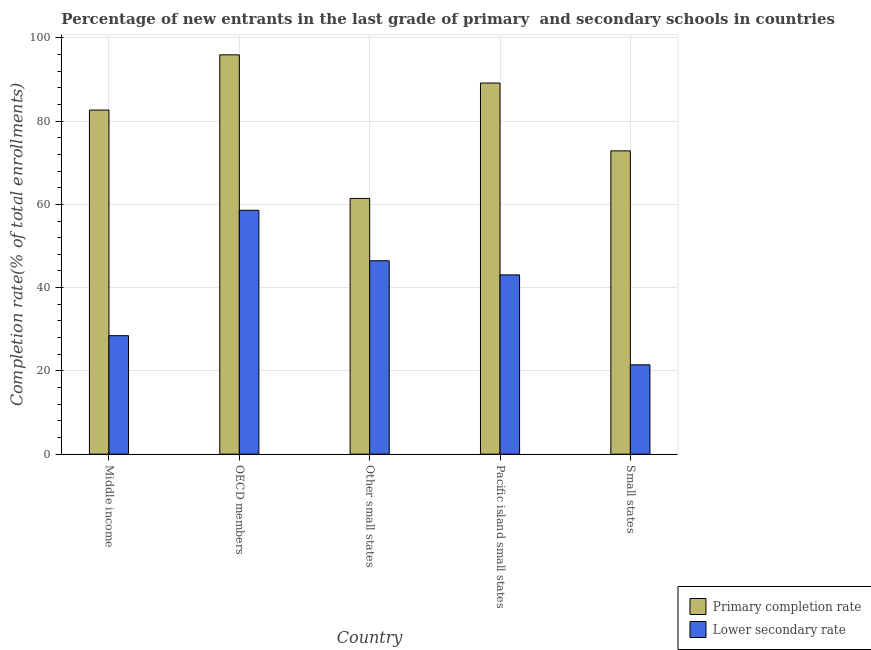How many groups of bars are there?
Make the answer very short. 5. How many bars are there on the 2nd tick from the left?
Provide a short and direct response. 2. What is the completion rate in secondary schools in Small states?
Offer a terse response. 21.46. Across all countries, what is the maximum completion rate in primary schools?
Ensure brevity in your answer.  95.91. Across all countries, what is the minimum completion rate in secondary schools?
Your answer should be compact. 21.46. In which country was the completion rate in secondary schools maximum?
Keep it short and to the point. OECD members. In which country was the completion rate in secondary schools minimum?
Keep it short and to the point. Small states. What is the total completion rate in secondary schools in the graph?
Keep it short and to the point. 198.01. What is the difference between the completion rate in primary schools in Other small states and that in Pacific island small states?
Your response must be concise. -27.72. What is the difference between the completion rate in secondary schools in Small states and the completion rate in primary schools in Other small states?
Your answer should be very brief. -39.96. What is the average completion rate in primary schools per country?
Your answer should be very brief. 80.4. What is the difference between the completion rate in secondary schools and completion rate in primary schools in Small states?
Provide a succinct answer. -51.39. What is the ratio of the completion rate in secondary schools in Pacific island small states to that in Small states?
Your answer should be compact. 2.01. Is the difference between the completion rate in primary schools in OECD members and Other small states greater than the difference between the completion rate in secondary schools in OECD members and Other small states?
Provide a succinct answer. Yes. What is the difference between the highest and the second highest completion rate in primary schools?
Your response must be concise. 6.76. What is the difference between the highest and the lowest completion rate in primary schools?
Give a very brief answer. 34.49. What does the 1st bar from the left in Small states represents?
Keep it short and to the point. Primary completion rate. What does the 2nd bar from the right in Pacific island small states represents?
Offer a terse response. Primary completion rate. Are all the bars in the graph horizontal?
Offer a very short reply. No. Are the values on the major ticks of Y-axis written in scientific E-notation?
Ensure brevity in your answer.  No. Does the graph contain grids?
Keep it short and to the point. Yes. Where does the legend appear in the graph?
Offer a very short reply. Bottom right. What is the title of the graph?
Provide a short and direct response. Percentage of new entrants in the last grade of primary  and secondary schools in countries. Does "constant 2005 US$" appear as one of the legend labels in the graph?
Your answer should be very brief. No. What is the label or title of the Y-axis?
Offer a terse response. Completion rate(% of total enrollments). What is the Completion rate(% of total enrollments) of Primary completion rate in Middle income?
Your answer should be compact. 82.65. What is the Completion rate(% of total enrollments) of Lower secondary rate in Middle income?
Your answer should be compact. 28.46. What is the Completion rate(% of total enrollments) in Primary completion rate in OECD members?
Offer a very short reply. 95.91. What is the Completion rate(% of total enrollments) of Lower secondary rate in OECD members?
Provide a succinct answer. 58.58. What is the Completion rate(% of total enrollments) of Primary completion rate in Other small states?
Provide a succinct answer. 61.43. What is the Completion rate(% of total enrollments) in Lower secondary rate in Other small states?
Provide a succinct answer. 46.45. What is the Completion rate(% of total enrollments) in Primary completion rate in Pacific island small states?
Make the answer very short. 89.15. What is the Completion rate(% of total enrollments) of Lower secondary rate in Pacific island small states?
Offer a terse response. 43.06. What is the Completion rate(% of total enrollments) of Primary completion rate in Small states?
Your answer should be very brief. 72.85. What is the Completion rate(% of total enrollments) in Lower secondary rate in Small states?
Give a very brief answer. 21.46. Across all countries, what is the maximum Completion rate(% of total enrollments) in Primary completion rate?
Provide a succinct answer. 95.91. Across all countries, what is the maximum Completion rate(% of total enrollments) in Lower secondary rate?
Keep it short and to the point. 58.58. Across all countries, what is the minimum Completion rate(% of total enrollments) in Primary completion rate?
Make the answer very short. 61.43. Across all countries, what is the minimum Completion rate(% of total enrollments) in Lower secondary rate?
Your answer should be compact. 21.46. What is the total Completion rate(% of total enrollments) in Primary completion rate in the graph?
Provide a succinct answer. 401.99. What is the total Completion rate(% of total enrollments) of Lower secondary rate in the graph?
Keep it short and to the point. 198.01. What is the difference between the Completion rate(% of total enrollments) of Primary completion rate in Middle income and that in OECD members?
Your answer should be very brief. -13.26. What is the difference between the Completion rate(% of total enrollments) of Lower secondary rate in Middle income and that in OECD members?
Keep it short and to the point. -30.12. What is the difference between the Completion rate(% of total enrollments) of Primary completion rate in Middle income and that in Other small states?
Give a very brief answer. 21.22. What is the difference between the Completion rate(% of total enrollments) in Lower secondary rate in Middle income and that in Other small states?
Make the answer very short. -17.99. What is the difference between the Completion rate(% of total enrollments) in Primary completion rate in Middle income and that in Pacific island small states?
Ensure brevity in your answer.  -6.5. What is the difference between the Completion rate(% of total enrollments) in Lower secondary rate in Middle income and that in Pacific island small states?
Give a very brief answer. -14.6. What is the difference between the Completion rate(% of total enrollments) of Primary completion rate in Middle income and that in Small states?
Provide a succinct answer. 9.8. What is the difference between the Completion rate(% of total enrollments) in Lower secondary rate in Middle income and that in Small states?
Offer a terse response. 7. What is the difference between the Completion rate(% of total enrollments) in Primary completion rate in OECD members and that in Other small states?
Your answer should be compact. 34.49. What is the difference between the Completion rate(% of total enrollments) of Lower secondary rate in OECD members and that in Other small states?
Offer a very short reply. 12.13. What is the difference between the Completion rate(% of total enrollments) of Primary completion rate in OECD members and that in Pacific island small states?
Give a very brief answer. 6.76. What is the difference between the Completion rate(% of total enrollments) of Lower secondary rate in OECD members and that in Pacific island small states?
Provide a short and direct response. 15.52. What is the difference between the Completion rate(% of total enrollments) in Primary completion rate in OECD members and that in Small states?
Make the answer very short. 23.06. What is the difference between the Completion rate(% of total enrollments) in Lower secondary rate in OECD members and that in Small states?
Provide a succinct answer. 37.11. What is the difference between the Completion rate(% of total enrollments) of Primary completion rate in Other small states and that in Pacific island small states?
Your response must be concise. -27.72. What is the difference between the Completion rate(% of total enrollments) of Lower secondary rate in Other small states and that in Pacific island small states?
Keep it short and to the point. 3.39. What is the difference between the Completion rate(% of total enrollments) of Primary completion rate in Other small states and that in Small states?
Your answer should be compact. -11.43. What is the difference between the Completion rate(% of total enrollments) in Lower secondary rate in Other small states and that in Small states?
Your response must be concise. 24.99. What is the difference between the Completion rate(% of total enrollments) in Primary completion rate in Pacific island small states and that in Small states?
Give a very brief answer. 16.3. What is the difference between the Completion rate(% of total enrollments) in Lower secondary rate in Pacific island small states and that in Small states?
Make the answer very short. 21.6. What is the difference between the Completion rate(% of total enrollments) in Primary completion rate in Middle income and the Completion rate(% of total enrollments) in Lower secondary rate in OECD members?
Offer a very short reply. 24.07. What is the difference between the Completion rate(% of total enrollments) in Primary completion rate in Middle income and the Completion rate(% of total enrollments) in Lower secondary rate in Other small states?
Ensure brevity in your answer.  36.2. What is the difference between the Completion rate(% of total enrollments) of Primary completion rate in Middle income and the Completion rate(% of total enrollments) of Lower secondary rate in Pacific island small states?
Your answer should be compact. 39.59. What is the difference between the Completion rate(% of total enrollments) of Primary completion rate in Middle income and the Completion rate(% of total enrollments) of Lower secondary rate in Small states?
Ensure brevity in your answer.  61.19. What is the difference between the Completion rate(% of total enrollments) of Primary completion rate in OECD members and the Completion rate(% of total enrollments) of Lower secondary rate in Other small states?
Your answer should be very brief. 49.46. What is the difference between the Completion rate(% of total enrollments) of Primary completion rate in OECD members and the Completion rate(% of total enrollments) of Lower secondary rate in Pacific island small states?
Make the answer very short. 52.85. What is the difference between the Completion rate(% of total enrollments) of Primary completion rate in OECD members and the Completion rate(% of total enrollments) of Lower secondary rate in Small states?
Your answer should be very brief. 74.45. What is the difference between the Completion rate(% of total enrollments) of Primary completion rate in Other small states and the Completion rate(% of total enrollments) of Lower secondary rate in Pacific island small states?
Make the answer very short. 18.37. What is the difference between the Completion rate(% of total enrollments) of Primary completion rate in Other small states and the Completion rate(% of total enrollments) of Lower secondary rate in Small states?
Ensure brevity in your answer.  39.96. What is the difference between the Completion rate(% of total enrollments) of Primary completion rate in Pacific island small states and the Completion rate(% of total enrollments) of Lower secondary rate in Small states?
Ensure brevity in your answer.  67.69. What is the average Completion rate(% of total enrollments) of Primary completion rate per country?
Provide a succinct answer. 80.4. What is the average Completion rate(% of total enrollments) of Lower secondary rate per country?
Your answer should be compact. 39.6. What is the difference between the Completion rate(% of total enrollments) in Primary completion rate and Completion rate(% of total enrollments) in Lower secondary rate in Middle income?
Give a very brief answer. 54.19. What is the difference between the Completion rate(% of total enrollments) of Primary completion rate and Completion rate(% of total enrollments) of Lower secondary rate in OECD members?
Give a very brief answer. 37.34. What is the difference between the Completion rate(% of total enrollments) of Primary completion rate and Completion rate(% of total enrollments) of Lower secondary rate in Other small states?
Offer a very short reply. 14.97. What is the difference between the Completion rate(% of total enrollments) in Primary completion rate and Completion rate(% of total enrollments) in Lower secondary rate in Pacific island small states?
Offer a terse response. 46.09. What is the difference between the Completion rate(% of total enrollments) of Primary completion rate and Completion rate(% of total enrollments) of Lower secondary rate in Small states?
Your response must be concise. 51.39. What is the ratio of the Completion rate(% of total enrollments) of Primary completion rate in Middle income to that in OECD members?
Offer a very short reply. 0.86. What is the ratio of the Completion rate(% of total enrollments) in Lower secondary rate in Middle income to that in OECD members?
Offer a very short reply. 0.49. What is the ratio of the Completion rate(% of total enrollments) in Primary completion rate in Middle income to that in Other small states?
Give a very brief answer. 1.35. What is the ratio of the Completion rate(% of total enrollments) of Lower secondary rate in Middle income to that in Other small states?
Your response must be concise. 0.61. What is the ratio of the Completion rate(% of total enrollments) of Primary completion rate in Middle income to that in Pacific island small states?
Offer a very short reply. 0.93. What is the ratio of the Completion rate(% of total enrollments) in Lower secondary rate in Middle income to that in Pacific island small states?
Make the answer very short. 0.66. What is the ratio of the Completion rate(% of total enrollments) in Primary completion rate in Middle income to that in Small states?
Your response must be concise. 1.13. What is the ratio of the Completion rate(% of total enrollments) in Lower secondary rate in Middle income to that in Small states?
Provide a short and direct response. 1.33. What is the ratio of the Completion rate(% of total enrollments) of Primary completion rate in OECD members to that in Other small states?
Your answer should be very brief. 1.56. What is the ratio of the Completion rate(% of total enrollments) in Lower secondary rate in OECD members to that in Other small states?
Offer a terse response. 1.26. What is the ratio of the Completion rate(% of total enrollments) of Primary completion rate in OECD members to that in Pacific island small states?
Your answer should be very brief. 1.08. What is the ratio of the Completion rate(% of total enrollments) in Lower secondary rate in OECD members to that in Pacific island small states?
Make the answer very short. 1.36. What is the ratio of the Completion rate(% of total enrollments) of Primary completion rate in OECD members to that in Small states?
Give a very brief answer. 1.32. What is the ratio of the Completion rate(% of total enrollments) of Lower secondary rate in OECD members to that in Small states?
Provide a succinct answer. 2.73. What is the ratio of the Completion rate(% of total enrollments) in Primary completion rate in Other small states to that in Pacific island small states?
Offer a terse response. 0.69. What is the ratio of the Completion rate(% of total enrollments) in Lower secondary rate in Other small states to that in Pacific island small states?
Provide a short and direct response. 1.08. What is the ratio of the Completion rate(% of total enrollments) in Primary completion rate in Other small states to that in Small states?
Ensure brevity in your answer.  0.84. What is the ratio of the Completion rate(% of total enrollments) of Lower secondary rate in Other small states to that in Small states?
Your response must be concise. 2.16. What is the ratio of the Completion rate(% of total enrollments) of Primary completion rate in Pacific island small states to that in Small states?
Make the answer very short. 1.22. What is the ratio of the Completion rate(% of total enrollments) in Lower secondary rate in Pacific island small states to that in Small states?
Your response must be concise. 2.01. What is the difference between the highest and the second highest Completion rate(% of total enrollments) of Primary completion rate?
Your response must be concise. 6.76. What is the difference between the highest and the second highest Completion rate(% of total enrollments) in Lower secondary rate?
Give a very brief answer. 12.13. What is the difference between the highest and the lowest Completion rate(% of total enrollments) of Primary completion rate?
Offer a terse response. 34.49. What is the difference between the highest and the lowest Completion rate(% of total enrollments) of Lower secondary rate?
Offer a very short reply. 37.11. 